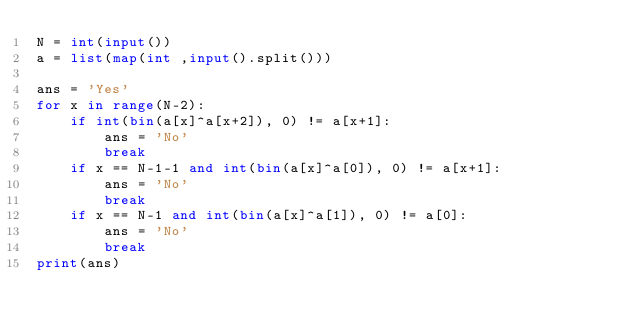Convert code to text. <code><loc_0><loc_0><loc_500><loc_500><_Python_>N = int(input())
a = list(map(int ,input().split()))

ans = 'Yes'
for x in range(N-2):
    if int(bin(a[x]^a[x+2]), 0) != a[x+1]:
        ans = 'No'
        break
    if x == N-1-1 and int(bin(a[x]^a[0]), 0) != a[x+1]:
        ans = 'No'
        break
    if x == N-1 and int(bin(a[x]^a[1]), 0) != a[0]:
        ans = 'No'
        break
print(ans)            </code> 